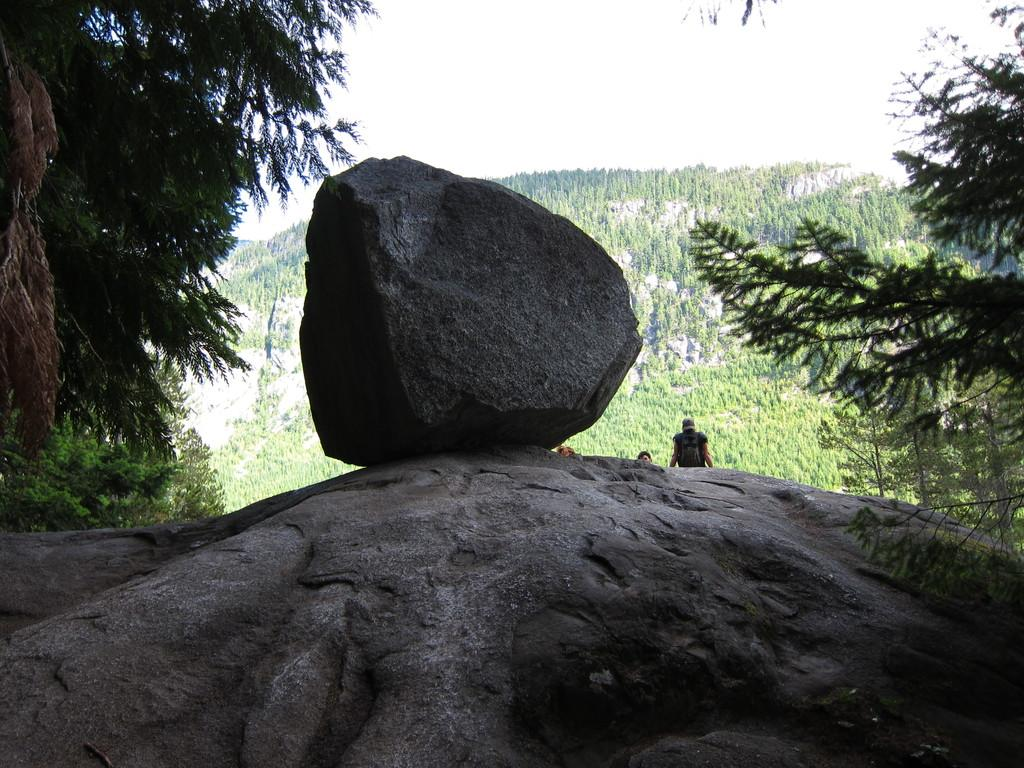What is in the foreground of the image? There are rocks in the foreground of the image. What can be seen on both sides of the image? There are trees on either side of the image. What is visible in the background of the image? There are people, trees on the slope ground, and the sky in the background of the image. What type of suit is the chair wearing in the image? There is no chair or suit present in the image. How many points does the rock have in the foreground of the image? The rocks in the foreground do not have points; they are solid objects. 